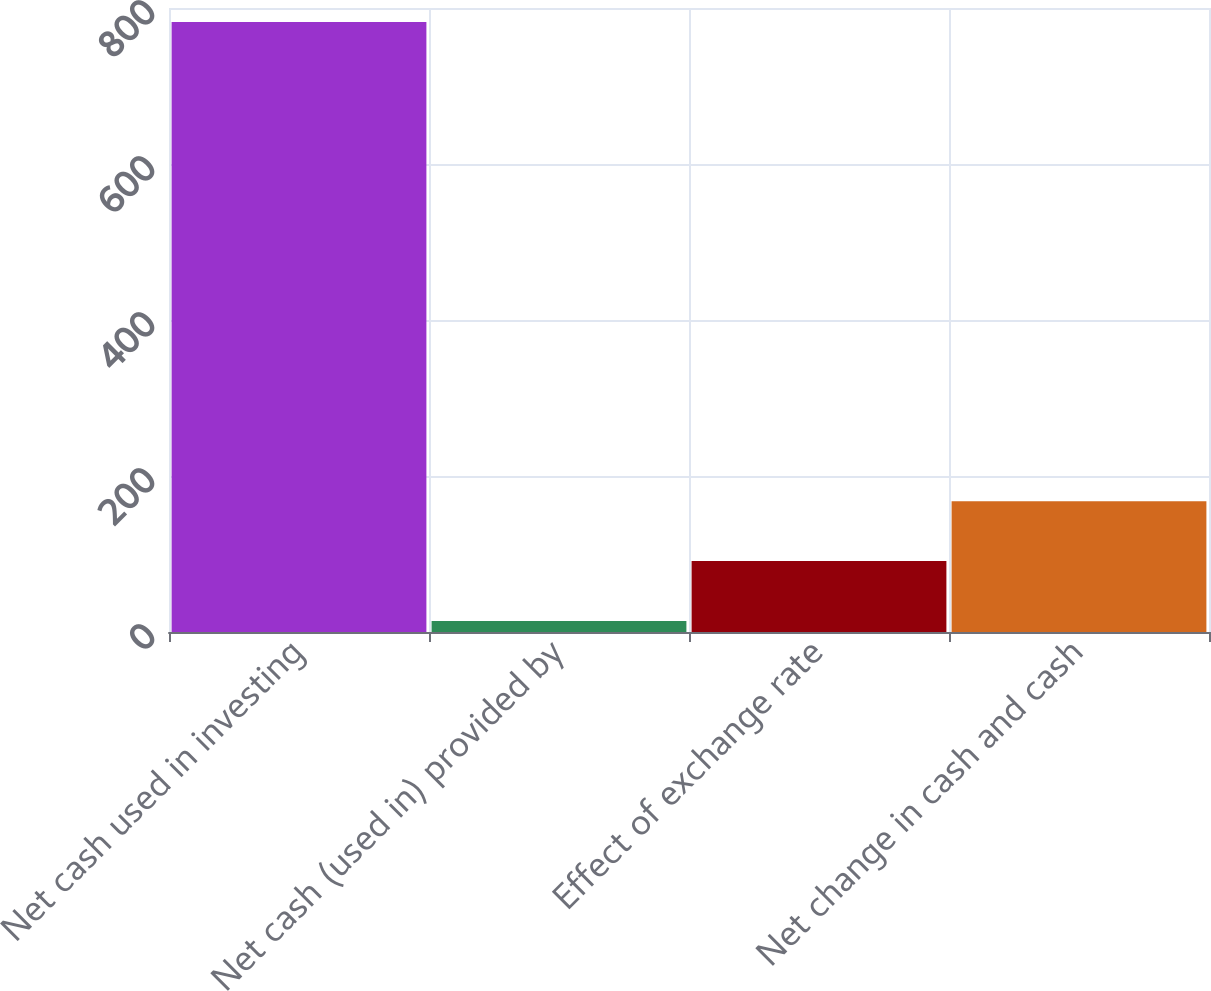Convert chart to OTSL. <chart><loc_0><loc_0><loc_500><loc_500><bar_chart><fcel>Net cash used in investing<fcel>Net cash (used in) provided by<fcel>Effect of exchange rate<fcel>Net change in cash and cash<nl><fcel>781.9<fcel>14.1<fcel>90.88<fcel>167.66<nl></chart> 